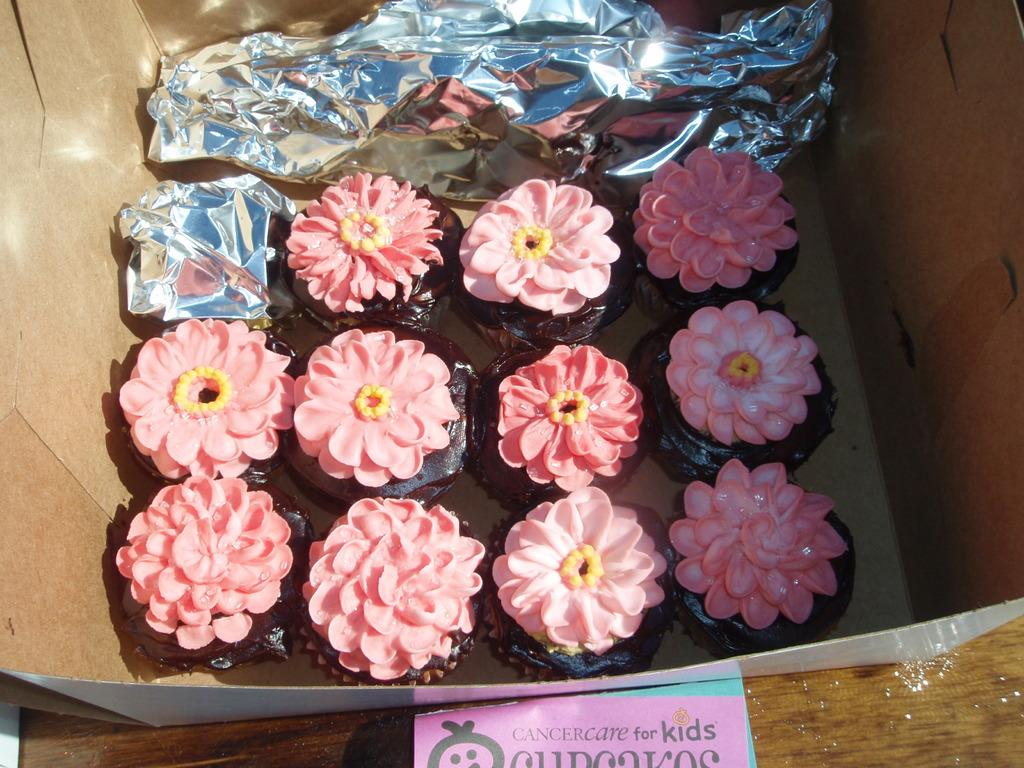What is placed in the center of the image? There are cakes placed in a box in the center of the image. Can you describe the background of the image? There is a table in the background of the image. How many clocks can be seen on the cakes in the image? There are no clocks visible on the cakes in the image. What action is being performed on the cakes in the image? The image does not depict any action being performed on the cakes. 